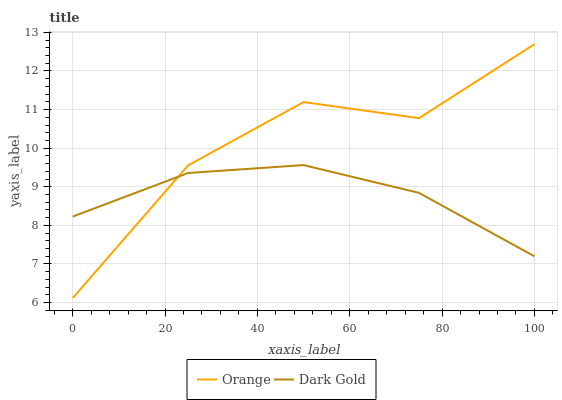Does Dark Gold have the maximum area under the curve?
Answer yes or no. No. Is Dark Gold the roughest?
Answer yes or no. No. Does Dark Gold have the lowest value?
Answer yes or no. No. Does Dark Gold have the highest value?
Answer yes or no. No. 